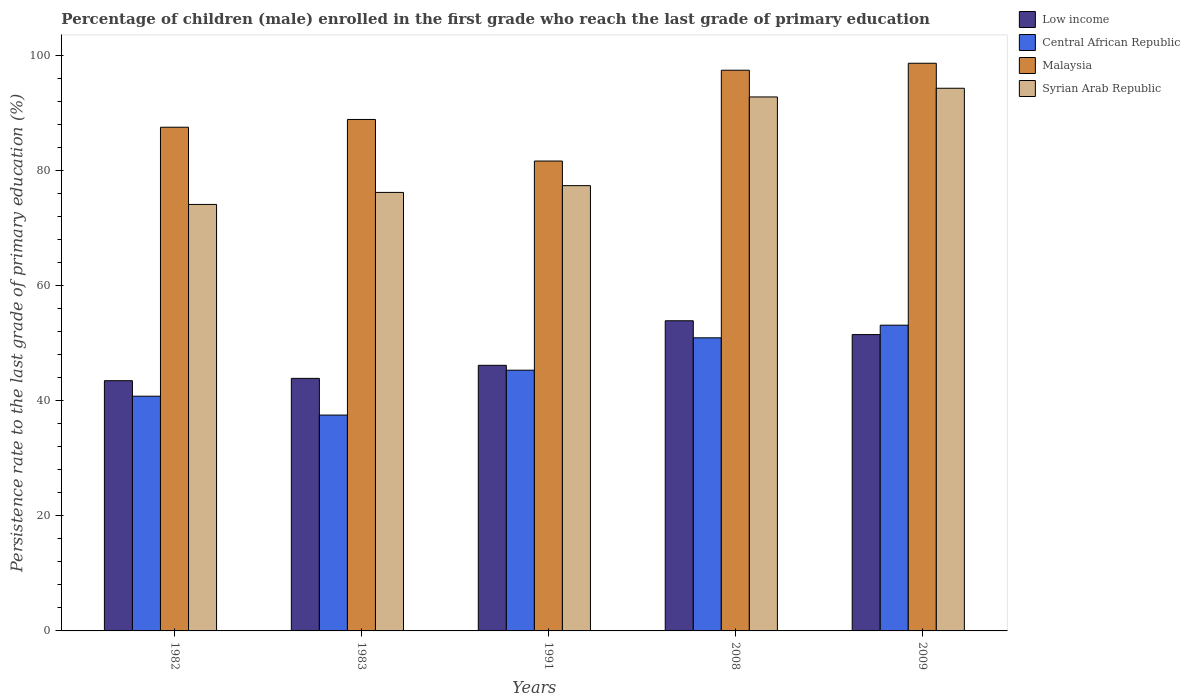How many groups of bars are there?
Keep it short and to the point. 5. How many bars are there on the 2nd tick from the right?
Your response must be concise. 4. In how many cases, is the number of bars for a given year not equal to the number of legend labels?
Offer a very short reply. 0. What is the persistence rate of children in Syrian Arab Republic in 1991?
Offer a very short reply. 77.38. Across all years, what is the maximum persistence rate of children in Central African Republic?
Your response must be concise. 53.13. Across all years, what is the minimum persistence rate of children in Syrian Arab Republic?
Make the answer very short. 74.12. What is the total persistence rate of children in Low income in the graph?
Your answer should be compact. 238.94. What is the difference between the persistence rate of children in Syrian Arab Republic in 1991 and that in 2008?
Your response must be concise. -15.42. What is the difference between the persistence rate of children in Malaysia in 2009 and the persistence rate of children in Central African Republic in 1991?
Offer a terse response. 53.34. What is the average persistence rate of children in Syrian Arab Republic per year?
Your answer should be compact. 82.96. In the year 1983, what is the difference between the persistence rate of children in Central African Republic and persistence rate of children in Malaysia?
Provide a short and direct response. -51.37. What is the ratio of the persistence rate of children in Malaysia in 1982 to that in 2009?
Make the answer very short. 0.89. Is the difference between the persistence rate of children in Central African Republic in 1991 and 2008 greater than the difference between the persistence rate of children in Malaysia in 1991 and 2008?
Offer a terse response. Yes. What is the difference between the highest and the second highest persistence rate of children in Central African Republic?
Provide a short and direct response. 2.2. What is the difference between the highest and the lowest persistence rate of children in Low income?
Keep it short and to the point. 10.42. In how many years, is the persistence rate of children in Malaysia greater than the average persistence rate of children in Malaysia taken over all years?
Offer a terse response. 2. Is the sum of the persistence rate of children in Malaysia in 2008 and 2009 greater than the maximum persistence rate of children in Central African Republic across all years?
Keep it short and to the point. Yes. What does the 4th bar from the left in 1982 represents?
Offer a terse response. Syrian Arab Republic. Are all the bars in the graph horizontal?
Give a very brief answer. No. How many years are there in the graph?
Give a very brief answer. 5. What is the difference between two consecutive major ticks on the Y-axis?
Ensure brevity in your answer.  20. Are the values on the major ticks of Y-axis written in scientific E-notation?
Provide a succinct answer. No. Does the graph contain grids?
Offer a terse response. No. Where does the legend appear in the graph?
Ensure brevity in your answer.  Top right. What is the title of the graph?
Offer a very short reply. Percentage of children (male) enrolled in the first grade who reach the last grade of primary education. What is the label or title of the X-axis?
Provide a succinct answer. Years. What is the label or title of the Y-axis?
Make the answer very short. Persistence rate to the last grade of primary education (%). What is the Persistence rate to the last grade of primary education (%) of Low income in 1982?
Your answer should be very brief. 43.49. What is the Persistence rate to the last grade of primary education (%) of Central African Republic in 1982?
Keep it short and to the point. 40.79. What is the Persistence rate to the last grade of primary education (%) of Malaysia in 1982?
Offer a very short reply. 87.54. What is the Persistence rate to the last grade of primary education (%) of Syrian Arab Republic in 1982?
Your response must be concise. 74.12. What is the Persistence rate to the last grade of primary education (%) of Low income in 1983?
Offer a terse response. 43.89. What is the Persistence rate to the last grade of primary education (%) of Central African Republic in 1983?
Your answer should be compact. 37.51. What is the Persistence rate to the last grade of primary education (%) in Malaysia in 1983?
Offer a terse response. 88.88. What is the Persistence rate to the last grade of primary education (%) of Syrian Arab Republic in 1983?
Offer a very short reply. 76.21. What is the Persistence rate to the last grade of primary education (%) in Low income in 1991?
Provide a succinct answer. 46.16. What is the Persistence rate to the last grade of primary education (%) in Central African Republic in 1991?
Give a very brief answer. 45.31. What is the Persistence rate to the last grade of primary education (%) of Malaysia in 1991?
Offer a terse response. 81.66. What is the Persistence rate to the last grade of primary education (%) of Syrian Arab Republic in 1991?
Make the answer very short. 77.38. What is the Persistence rate to the last grade of primary education (%) of Low income in 2008?
Offer a terse response. 53.9. What is the Persistence rate to the last grade of primary education (%) of Central African Republic in 2008?
Your response must be concise. 50.94. What is the Persistence rate to the last grade of primary education (%) of Malaysia in 2008?
Provide a short and direct response. 97.44. What is the Persistence rate to the last grade of primary education (%) in Syrian Arab Republic in 2008?
Ensure brevity in your answer.  92.8. What is the Persistence rate to the last grade of primary education (%) in Low income in 2009?
Offer a terse response. 51.5. What is the Persistence rate to the last grade of primary education (%) of Central African Republic in 2009?
Keep it short and to the point. 53.13. What is the Persistence rate to the last grade of primary education (%) of Malaysia in 2009?
Offer a terse response. 98.65. What is the Persistence rate to the last grade of primary education (%) of Syrian Arab Republic in 2009?
Your answer should be compact. 94.31. Across all years, what is the maximum Persistence rate to the last grade of primary education (%) of Low income?
Provide a short and direct response. 53.9. Across all years, what is the maximum Persistence rate to the last grade of primary education (%) of Central African Republic?
Offer a terse response. 53.13. Across all years, what is the maximum Persistence rate to the last grade of primary education (%) in Malaysia?
Give a very brief answer. 98.65. Across all years, what is the maximum Persistence rate to the last grade of primary education (%) in Syrian Arab Republic?
Offer a very short reply. 94.31. Across all years, what is the minimum Persistence rate to the last grade of primary education (%) of Low income?
Your answer should be very brief. 43.49. Across all years, what is the minimum Persistence rate to the last grade of primary education (%) in Central African Republic?
Your response must be concise. 37.51. Across all years, what is the minimum Persistence rate to the last grade of primary education (%) of Malaysia?
Keep it short and to the point. 81.66. Across all years, what is the minimum Persistence rate to the last grade of primary education (%) in Syrian Arab Republic?
Your response must be concise. 74.12. What is the total Persistence rate to the last grade of primary education (%) in Low income in the graph?
Ensure brevity in your answer.  238.94. What is the total Persistence rate to the last grade of primary education (%) of Central African Republic in the graph?
Give a very brief answer. 227.69. What is the total Persistence rate to the last grade of primary education (%) in Malaysia in the graph?
Your answer should be compact. 454.17. What is the total Persistence rate to the last grade of primary education (%) in Syrian Arab Republic in the graph?
Offer a very short reply. 414.82. What is the difference between the Persistence rate to the last grade of primary education (%) in Low income in 1982 and that in 1983?
Make the answer very short. -0.41. What is the difference between the Persistence rate to the last grade of primary education (%) in Central African Republic in 1982 and that in 1983?
Ensure brevity in your answer.  3.28. What is the difference between the Persistence rate to the last grade of primary education (%) of Malaysia in 1982 and that in 1983?
Give a very brief answer. -1.35. What is the difference between the Persistence rate to the last grade of primary education (%) of Syrian Arab Republic in 1982 and that in 1983?
Provide a short and direct response. -2.09. What is the difference between the Persistence rate to the last grade of primary education (%) in Low income in 1982 and that in 1991?
Offer a very short reply. -2.67. What is the difference between the Persistence rate to the last grade of primary education (%) in Central African Republic in 1982 and that in 1991?
Ensure brevity in your answer.  -4.52. What is the difference between the Persistence rate to the last grade of primary education (%) in Malaysia in 1982 and that in 1991?
Make the answer very short. 5.88. What is the difference between the Persistence rate to the last grade of primary education (%) in Syrian Arab Republic in 1982 and that in 1991?
Give a very brief answer. -3.26. What is the difference between the Persistence rate to the last grade of primary education (%) in Low income in 1982 and that in 2008?
Provide a succinct answer. -10.42. What is the difference between the Persistence rate to the last grade of primary education (%) of Central African Republic in 1982 and that in 2008?
Provide a succinct answer. -10.14. What is the difference between the Persistence rate to the last grade of primary education (%) in Malaysia in 1982 and that in 2008?
Ensure brevity in your answer.  -9.91. What is the difference between the Persistence rate to the last grade of primary education (%) of Syrian Arab Republic in 1982 and that in 2008?
Make the answer very short. -18.68. What is the difference between the Persistence rate to the last grade of primary education (%) of Low income in 1982 and that in 2009?
Provide a short and direct response. -8.02. What is the difference between the Persistence rate to the last grade of primary education (%) in Central African Republic in 1982 and that in 2009?
Make the answer very short. -12.34. What is the difference between the Persistence rate to the last grade of primary education (%) in Malaysia in 1982 and that in 2009?
Keep it short and to the point. -11.12. What is the difference between the Persistence rate to the last grade of primary education (%) in Syrian Arab Republic in 1982 and that in 2009?
Provide a short and direct response. -20.19. What is the difference between the Persistence rate to the last grade of primary education (%) of Low income in 1983 and that in 1991?
Offer a very short reply. -2.27. What is the difference between the Persistence rate to the last grade of primary education (%) of Central African Republic in 1983 and that in 1991?
Make the answer very short. -7.8. What is the difference between the Persistence rate to the last grade of primary education (%) in Malaysia in 1983 and that in 1991?
Keep it short and to the point. 7.23. What is the difference between the Persistence rate to the last grade of primary education (%) of Syrian Arab Republic in 1983 and that in 1991?
Your response must be concise. -1.18. What is the difference between the Persistence rate to the last grade of primary education (%) of Low income in 1983 and that in 2008?
Offer a terse response. -10.01. What is the difference between the Persistence rate to the last grade of primary education (%) in Central African Republic in 1983 and that in 2008?
Give a very brief answer. -13.43. What is the difference between the Persistence rate to the last grade of primary education (%) in Malaysia in 1983 and that in 2008?
Make the answer very short. -8.56. What is the difference between the Persistence rate to the last grade of primary education (%) in Syrian Arab Republic in 1983 and that in 2008?
Give a very brief answer. -16.59. What is the difference between the Persistence rate to the last grade of primary education (%) of Low income in 1983 and that in 2009?
Provide a succinct answer. -7.61. What is the difference between the Persistence rate to the last grade of primary education (%) of Central African Republic in 1983 and that in 2009?
Provide a short and direct response. -15.62. What is the difference between the Persistence rate to the last grade of primary education (%) in Malaysia in 1983 and that in 2009?
Your answer should be compact. -9.77. What is the difference between the Persistence rate to the last grade of primary education (%) in Syrian Arab Republic in 1983 and that in 2009?
Ensure brevity in your answer.  -18.1. What is the difference between the Persistence rate to the last grade of primary education (%) of Low income in 1991 and that in 2008?
Your answer should be compact. -7.74. What is the difference between the Persistence rate to the last grade of primary education (%) in Central African Republic in 1991 and that in 2008?
Make the answer very short. -5.63. What is the difference between the Persistence rate to the last grade of primary education (%) of Malaysia in 1991 and that in 2008?
Provide a succinct answer. -15.78. What is the difference between the Persistence rate to the last grade of primary education (%) in Syrian Arab Republic in 1991 and that in 2008?
Your answer should be very brief. -15.42. What is the difference between the Persistence rate to the last grade of primary education (%) of Low income in 1991 and that in 2009?
Offer a very short reply. -5.34. What is the difference between the Persistence rate to the last grade of primary education (%) in Central African Republic in 1991 and that in 2009?
Provide a short and direct response. -7.82. What is the difference between the Persistence rate to the last grade of primary education (%) in Malaysia in 1991 and that in 2009?
Your answer should be very brief. -16.99. What is the difference between the Persistence rate to the last grade of primary education (%) of Syrian Arab Republic in 1991 and that in 2009?
Offer a very short reply. -16.92. What is the difference between the Persistence rate to the last grade of primary education (%) in Central African Republic in 2008 and that in 2009?
Provide a succinct answer. -2.2. What is the difference between the Persistence rate to the last grade of primary education (%) in Malaysia in 2008 and that in 2009?
Make the answer very short. -1.21. What is the difference between the Persistence rate to the last grade of primary education (%) of Syrian Arab Republic in 2008 and that in 2009?
Keep it short and to the point. -1.51. What is the difference between the Persistence rate to the last grade of primary education (%) of Low income in 1982 and the Persistence rate to the last grade of primary education (%) of Central African Republic in 1983?
Give a very brief answer. 5.98. What is the difference between the Persistence rate to the last grade of primary education (%) of Low income in 1982 and the Persistence rate to the last grade of primary education (%) of Malaysia in 1983?
Make the answer very short. -45.4. What is the difference between the Persistence rate to the last grade of primary education (%) of Low income in 1982 and the Persistence rate to the last grade of primary education (%) of Syrian Arab Republic in 1983?
Your answer should be very brief. -32.72. What is the difference between the Persistence rate to the last grade of primary education (%) in Central African Republic in 1982 and the Persistence rate to the last grade of primary education (%) in Malaysia in 1983?
Offer a very short reply. -48.09. What is the difference between the Persistence rate to the last grade of primary education (%) in Central African Republic in 1982 and the Persistence rate to the last grade of primary education (%) in Syrian Arab Republic in 1983?
Offer a very short reply. -35.41. What is the difference between the Persistence rate to the last grade of primary education (%) of Malaysia in 1982 and the Persistence rate to the last grade of primary education (%) of Syrian Arab Republic in 1983?
Your answer should be very brief. 11.33. What is the difference between the Persistence rate to the last grade of primary education (%) of Low income in 1982 and the Persistence rate to the last grade of primary education (%) of Central African Republic in 1991?
Offer a terse response. -1.83. What is the difference between the Persistence rate to the last grade of primary education (%) of Low income in 1982 and the Persistence rate to the last grade of primary education (%) of Malaysia in 1991?
Ensure brevity in your answer.  -38.17. What is the difference between the Persistence rate to the last grade of primary education (%) of Low income in 1982 and the Persistence rate to the last grade of primary education (%) of Syrian Arab Republic in 1991?
Make the answer very short. -33.9. What is the difference between the Persistence rate to the last grade of primary education (%) of Central African Republic in 1982 and the Persistence rate to the last grade of primary education (%) of Malaysia in 1991?
Provide a short and direct response. -40.87. What is the difference between the Persistence rate to the last grade of primary education (%) of Central African Republic in 1982 and the Persistence rate to the last grade of primary education (%) of Syrian Arab Republic in 1991?
Offer a terse response. -36.59. What is the difference between the Persistence rate to the last grade of primary education (%) in Malaysia in 1982 and the Persistence rate to the last grade of primary education (%) in Syrian Arab Republic in 1991?
Provide a succinct answer. 10.15. What is the difference between the Persistence rate to the last grade of primary education (%) of Low income in 1982 and the Persistence rate to the last grade of primary education (%) of Central African Republic in 2008?
Offer a very short reply. -7.45. What is the difference between the Persistence rate to the last grade of primary education (%) in Low income in 1982 and the Persistence rate to the last grade of primary education (%) in Malaysia in 2008?
Your answer should be very brief. -53.96. What is the difference between the Persistence rate to the last grade of primary education (%) in Low income in 1982 and the Persistence rate to the last grade of primary education (%) in Syrian Arab Republic in 2008?
Provide a succinct answer. -49.31. What is the difference between the Persistence rate to the last grade of primary education (%) in Central African Republic in 1982 and the Persistence rate to the last grade of primary education (%) in Malaysia in 2008?
Keep it short and to the point. -56.65. What is the difference between the Persistence rate to the last grade of primary education (%) of Central African Republic in 1982 and the Persistence rate to the last grade of primary education (%) of Syrian Arab Republic in 2008?
Make the answer very short. -52.01. What is the difference between the Persistence rate to the last grade of primary education (%) of Malaysia in 1982 and the Persistence rate to the last grade of primary education (%) of Syrian Arab Republic in 2008?
Provide a short and direct response. -5.26. What is the difference between the Persistence rate to the last grade of primary education (%) in Low income in 1982 and the Persistence rate to the last grade of primary education (%) in Central African Republic in 2009?
Your answer should be compact. -9.65. What is the difference between the Persistence rate to the last grade of primary education (%) in Low income in 1982 and the Persistence rate to the last grade of primary education (%) in Malaysia in 2009?
Your response must be concise. -55.17. What is the difference between the Persistence rate to the last grade of primary education (%) of Low income in 1982 and the Persistence rate to the last grade of primary education (%) of Syrian Arab Republic in 2009?
Give a very brief answer. -50.82. What is the difference between the Persistence rate to the last grade of primary education (%) in Central African Republic in 1982 and the Persistence rate to the last grade of primary education (%) in Malaysia in 2009?
Your answer should be compact. -57.86. What is the difference between the Persistence rate to the last grade of primary education (%) of Central African Republic in 1982 and the Persistence rate to the last grade of primary education (%) of Syrian Arab Republic in 2009?
Give a very brief answer. -53.52. What is the difference between the Persistence rate to the last grade of primary education (%) of Malaysia in 1982 and the Persistence rate to the last grade of primary education (%) of Syrian Arab Republic in 2009?
Keep it short and to the point. -6.77. What is the difference between the Persistence rate to the last grade of primary education (%) in Low income in 1983 and the Persistence rate to the last grade of primary education (%) in Central African Republic in 1991?
Your response must be concise. -1.42. What is the difference between the Persistence rate to the last grade of primary education (%) in Low income in 1983 and the Persistence rate to the last grade of primary education (%) in Malaysia in 1991?
Ensure brevity in your answer.  -37.77. What is the difference between the Persistence rate to the last grade of primary education (%) in Low income in 1983 and the Persistence rate to the last grade of primary education (%) in Syrian Arab Republic in 1991?
Provide a short and direct response. -33.49. What is the difference between the Persistence rate to the last grade of primary education (%) of Central African Republic in 1983 and the Persistence rate to the last grade of primary education (%) of Malaysia in 1991?
Provide a short and direct response. -44.15. What is the difference between the Persistence rate to the last grade of primary education (%) of Central African Republic in 1983 and the Persistence rate to the last grade of primary education (%) of Syrian Arab Republic in 1991?
Your answer should be compact. -39.87. What is the difference between the Persistence rate to the last grade of primary education (%) of Malaysia in 1983 and the Persistence rate to the last grade of primary education (%) of Syrian Arab Republic in 1991?
Make the answer very short. 11.5. What is the difference between the Persistence rate to the last grade of primary education (%) in Low income in 1983 and the Persistence rate to the last grade of primary education (%) in Central African Republic in 2008?
Offer a very short reply. -7.05. What is the difference between the Persistence rate to the last grade of primary education (%) in Low income in 1983 and the Persistence rate to the last grade of primary education (%) in Malaysia in 2008?
Your response must be concise. -53.55. What is the difference between the Persistence rate to the last grade of primary education (%) in Low income in 1983 and the Persistence rate to the last grade of primary education (%) in Syrian Arab Republic in 2008?
Ensure brevity in your answer.  -48.91. What is the difference between the Persistence rate to the last grade of primary education (%) in Central African Republic in 1983 and the Persistence rate to the last grade of primary education (%) in Malaysia in 2008?
Provide a succinct answer. -59.93. What is the difference between the Persistence rate to the last grade of primary education (%) of Central African Republic in 1983 and the Persistence rate to the last grade of primary education (%) of Syrian Arab Republic in 2008?
Ensure brevity in your answer.  -55.29. What is the difference between the Persistence rate to the last grade of primary education (%) in Malaysia in 1983 and the Persistence rate to the last grade of primary education (%) in Syrian Arab Republic in 2008?
Offer a terse response. -3.92. What is the difference between the Persistence rate to the last grade of primary education (%) in Low income in 1983 and the Persistence rate to the last grade of primary education (%) in Central African Republic in 2009?
Provide a short and direct response. -9.24. What is the difference between the Persistence rate to the last grade of primary education (%) in Low income in 1983 and the Persistence rate to the last grade of primary education (%) in Malaysia in 2009?
Keep it short and to the point. -54.76. What is the difference between the Persistence rate to the last grade of primary education (%) in Low income in 1983 and the Persistence rate to the last grade of primary education (%) in Syrian Arab Republic in 2009?
Your response must be concise. -50.42. What is the difference between the Persistence rate to the last grade of primary education (%) in Central African Republic in 1983 and the Persistence rate to the last grade of primary education (%) in Malaysia in 2009?
Your answer should be compact. -61.14. What is the difference between the Persistence rate to the last grade of primary education (%) in Central African Republic in 1983 and the Persistence rate to the last grade of primary education (%) in Syrian Arab Republic in 2009?
Ensure brevity in your answer.  -56.8. What is the difference between the Persistence rate to the last grade of primary education (%) of Malaysia in 1983 and the Persistence rate to the last grade of primary education (%) of Syrian Arab Republic in 2009?
Your answer should be compact. -5.42. What is the difference between the Persistence rate to the last grade of primary education (%) in Low income in 1991 and the Persistence rate to the last grade of primary education (%) in Central African Republic in 2008?
Give a very brief answer. -4.78. What is the difference between the Persistence rate to the last grade of primary education (%) of Low income in 1991 and the Persistence rate to the last grade of primary education (%) of Malaysia in 2008?
Keep it short and to the point. -51.28. What is the difference between the Persistence rate to the last grade of primary education (%) of Low income in 1991 and the Persistence rate to the last grade of primary education (%) of Syrian Arab Republic in 2008?
Ensure brevity in your answer.  -46.64. What is the difference between the Persistence rate to the last grade of primary education (%) of Central African Republic in 1991 and the Persistence rate to the last grade of primary education (%) of Malaysia in 2008?
Your answer should be very brief. -52.13. What is the difference between the Persistence rate to the last grade of primary education (%) of Central African Republic in 1991 and the Persistence rate to the last grade of primary education (%) of Syrian Arab Republic in 2008?
Your answer should be very brief. -47.49. What is the difference between the Persistence rate to the last grade of primary education (%) in Malaysia in 1991 and the Persistence rate to the last grade of primary education (%) in Syrian Arab Republic in 2008?
Your answer should be very brief. -11.14. What is the difference between the Persistence rate to the last grade of primary education (%) in Low income in 1991 and the Persistence rate to the last grade of primary education (%) in Central African Republic in 2009?
Ensure brevity in your answer.  -6.98. What is the difference between the Persistence rate to the last grade of primary education (%) of Low income in 1991 and the Persistence rate to the last grade of primary education (%) of Malaysia in 2009?
Ensure brevity in your answer.  -52.49. What is the difference between the Persistence rate to the last grade of primary education (%) of Low income in 1991 and the Persistence rate to the last grade of primary education (%) of Syrian Arab Republic in 2009?
Provide a short and direct response. -48.15. What is the difference between the Persistence rate to the last grade of primary education (%) in Central African Republic in 1991 and the Persistence rate to the last grade of primary education (%) in Malaysia in 2009?
Make the answer very short. -53.34. What is the difference between the Persistence rate to the last grade of primary education (%) in Central African Republic in 1991 and the Persistence rate to the last grade of primary education (%) in Syrian Arab Republic in 2009?
Your answer should be very brief. -49. What is the difference between the Persistence rate to the last grade of primary education (%) in Malaysia in 1991 and the Persistence rate to the last grade of primary education (%) in Syrian Arab Republic in 2009?
Provide a succinct answer. -12.65. What is the difference between the Persistence rate to the last grade of primary education (%) in Low income in 2008 and the Persistence rate to the last grade of primary education (%) in Central African Republic in 2009?
Your answer should be very brief. 0.77. What is the difference between the Persistence rate to the last grade of primary education (%) of Low income in 2008 and the Persistence rate to the last grade of primary education (%) of Malaysia in 2009?
Make the answer very short. -44.75. What is the difference between the Persistence rate to the last grade of primary education (%) of Low income in 2008 and the Persistence rate to the last grade of primary education (%) of Syrian Arab Republic in 2009?
Your response must be concise. -40.41. What is the difference between the Persistence rate to the last grade of primary education (%) in Central African Republic in 2008 and the Persistence rate to the last grade of primary education (%) in Malaysia in 2009?
Your response must be concise. -47.72. What is the difference between the Persistence rate to the last grade of primary education (%) in Central African Republic in 2008 and the Persistence rate to the last grade of primary education (%) in Syrian Arab Republic in 2009?
Ensure brevity in your answer.  -43.37. What is the difference between the Persistence rate to the last grade of primary education (%) in Malaysia in 2008 and the Persistence rate to the last grade of primary education (%) in Syrian Arab Republic in 2009?
Your answer should be very brief. 3.13. What is the average Persistence rate to the last grade of primary education (%) in Low income per year?
Provide a succinct answer. 47.79. What is the average Persistence rate to the last grade of primary education (%) of Central African Republic per year?
Offer a very short reply. 45.54. What is the average Persistence rate to the last grade of primary education (%) of Malaysia per year?
Offer a terse response. 90.83. What is the average Persistence rate to the last grade of primary education (%) in Syrian Arab Republic per year?
Your answer should be very brief. 82.96. In the year 1982, what is the difference between the Persistence rate to the last grade of primary education (%) of Low income and Persistence rate to the last grade of primary education (%) of Central African Republic?
Provide a succinct answer. 2.69. In the year 1982, what is the difference between the Persistence rate to the last grade of primary education (%) of Low income and Persistence rate to the last grade of primary education (%) of Malaysia?
Make the answer very short. -44.05. In the year 1982, what is the difference between the Persistence rate to the last grade of primary education (%) in Low income and Persistence rate to the last grade of primary education (%) in Syrian Arab Republic?
Your answer should be very brief. -30.63. In the year 1982, what is the difference between the Persistence rate to the last grade of primary education (%) in Central African Republic and Persistence rate to the last grade of primary education (%) in Malaysia?
Offer a terse response. -46.74. In the year 1982, what is the difference between the Persistence rate to the last grade of primary education (%) of Central African Republic and Persistence rate to the last grade of primary education (%) of Syrian Arab Republic?
Ensure brevity in your answer.  -33.33. In the year 1982, what is the difference between the Persistence rate to the last grade of primary education (%) of Malaysia and Persistence rate to the last grade of primary education (%) of Syrian Arab Republic?
Your answer should be very brief. 13.42. In the year 1983, what is the difference between the Persistence rate to the last grade of primary education (%) in Low income and Persistence rate to the last grade of primary education (%) in Central African Republic?
Offer a very short reply. 6.38. In the year 1983, what is the difference between the Persistence rate to the last grade of primary education (%) of Low income and Persistence rate to the last grade of primary education (%) of Malaysia?
Provide a short and direct response. -44.99. In the year 1983, what is the difference between the Persistence rate to the last grade of primary education (%) in Low income and Persistence rate to the last grade of primary education (%) in Syrian Arab Republic?
Keep it short and to the point. -32.31. In the year 1983, what is the difference between the Persistence rate to the last grade of primary education (%) in Central African Republic and Persistence rate to the last grade of primary education (%) in Malaysia?
Keep it short and to the point. -51.37. In the year 1983, what is the difference between the Persistence rate to the last grade of primary education (%) of Central African Republic and Persistence rate to the last grade of primary education (%) of Syrian Arab Republic?
Keep it short and to the point. -38.7. In the year 1983, what is the difference between the Persistence rate to the last grade of primary education (%) in Malaysia and Persistence rate to the last grade of primary education (%) in Syrian Arab Republic?
Give a very brief answer. 12.68. In the year 1991, what is the difference between the Persistence rate to the last grade of primary education (%) in Low income and Persistence rate to the last grade of primary education (%) in Central African Republic?
Offer a very short reply. 0.85. In the year 1991, what is the difference between the Persistence rate to the last grade of primary education (%) in Low income and Persistence rate to the last grade of primary education (%) in Malaysia?
Offer a very short reply. -35.5. In the year 1991, what is the difference between the Persistence rate to the last grade of primary education (%) in Low income and Persistence rate to the last grade of primary education (%) in Syrian Arab Republic?
Your response must be concise. -31.23. In the year 1991, what is the difference between the Persistence rate to the last grade of primary education (%) in Central African Republic and Persistence rate to the last grade of primary education (%) in Malaysia?
Provide a short and direct response. -36.35. In the year 1991, what is the difference between the Persistence rate to the last grade of primary education (%) in Central African Republic and Persistence rate to the last grade of primary education (%) in Syrian Arab Republic?
Provide a short and direct response. -32.07. In the year 1991, what is the difference between the Persistence rate to the last grade of primary education (%) in Malaysia and Persistence rate to the last grade of primary education (%) in Syrian Arab Republic?
Your answer should be very brief. 4.27. In the year 2008, what is the difference between the Persistence rate to the last grade of primary education (%) of Low income and Persistence rate to the last grade of primary education (%) of Central African Republic?
Make the answer very short. 2.96. In the year 2008, what is the difference between the Persistence rate to the last grade of primary education (%) in Low income and Persistence rate to the last grade of primary education (%) in Malaysia?
Offer a very short reply. -43.54. In the year 2008, what is the difference between the Persistence rate to the last grade of primary education (%) in Low income and Persistence rate to the last grade of primary education (%) in Syrian Arab Republic?
Your answer should be very brief. -38.9. In the year 2008, what is the difference between the Persistence rate to the last grade of primary education (%) of Central African Republic and Persistence rate to the last grade of primary education (%) of Malaysia?
Give a very brief answer. -46.51. In the year 2008, what is the difference between the Persistence rate to the last grade of primary education (%) in Central African Republic and Persistence rate to the last grade of primary education (%) in Syrian Arab Republic?
Your answer should be compact. -41.86. In the year 2008, what is the difference between the Persistence rate to the last grade of primary education (%) of Malaysia and Persistence rate to the last grade of primary education (%) of Syrian Arab Republic?
Your answer should be very brief. 4.64. In the year 2009, what is the difference between the Persistence rate to the last grade of primary education (%) of Low income and Persistence rate to the last grade of primary education (%) of Central African Republic?
Provide a short and direct response. -1.63. In the year 2009, what is the difference between the Persistence rate to the last grade of primary education (%) of Low income and Persistence rate to the last grade of primary education (%) of Malaysia?
Your answer should be compact. -47.15. In the year 2009, what is the difference between the Persistence rate to the last grade of primary education (%) in Low income and Persistence rate to the last grade of primary education (%) in Syrian Arab Republic?
Offer a very short reply. -42.81. In the year 2009, what is the difference between the Persistence rate to the last grade of primary education (%) of Central African Republic and Persistence rate to the last grade of primary education (%) of Malaysia?
Your answer should be very brief. -45.52. In the year 2009, what is the difference between the Persistence rate to the last grade of primary education (%) of Central African Republic and Persistence rate to the last grade of primary education (%) of Syrian Arab Republic?
Keep it short and to the point. -41.17. In the year 2009, what is the difference between the Persistence rate to the last grade of primary education (%) of Malaysia and Persistence rate to the last grade of primary education (%) of Syrian Arab Republic?
Offer a terse response. 4.34. What is the ratio of the Persistence rate to the last grade of primary education (%) of Low income in 1982 to that in 1983?
Offer a terse response. 0.99. What is the ratio of the Persistence rate to the last grade of primary education (%) in Central African Republic in 1982 to that in 1983?
Provide a short and direct response. 1.09. What is the ratio of the Persistence rate to the last grade of primary education (%) of Malaysia in 1982 to that in 1983?
Provide a short and direct response. 0.98. What is the ratio of the Persistence rate to the last grade of primary education (%) in Syrian Arab Republic in 1982 to that in 1983?
Provide a short and direct response. 0.97. What is the ratio of the Persistence rate to the last grade of primary education (%) in Low income in 1982 to that in 1991?
Ensure brevity in your answer.  0.94. What is the ratio of the Persistence rate to the last grade of primary education (%) of Central African Republic in 1982 to that in 1991?
Your response must be concise. 0.9. What is the ratio of the Persistence rate to the last grade of primary education (%) in Malaysia in 1982 to that in 1991?
Keep it short and to the point. 1.07. What is the ratio of the Persistence rate to the last grade of primary education (%) in Syrian Arab Republic in 1982 to that in 1991?
Make the answer very short. 0.96. What is the ratio of the Persistence rate to the last grade of primary education (%) in Low income in 1982 to that in 2008?
Your response must be concise. 0.81. What is the ratio of the Persistence rate to the last grade of primary education (%) in Central African Republic in 1982 to that in 2008?
Provide a succinct answer. 0.8. What is the ratio of the Persistence rate to the last grade of primary education (%) of Malaysia in 1982 to that in 2008?
Offer a terse response. 0.9. What is the ratio of the Persistence rate to the last grade of primary education (%) of Syrian Arab Republic in 1982 to that in 2008?
Provide a succinct answer. 0.8. What is the ratio of the Persistence rate to the last grade of primary education (%) of Low income in 1982 to that in 2009?
Provide a short and direct response. 0.84. What is the ratio of the Persistence rate to the last grade of primary education (%) of Central African Republic in 1982 to that in 2009?
Give a very brief answer. 0.77. What is the ratio of the Persistence rate to the last grade of primary education (%) of Malaysia in 1982 to that in 2009?
Provide a succinct answer. 0.89. What is the ratio of the Persistence rate to the last grade of primary education (%) of Syrian Arab Republic in 1982 to that in 2009?
Offer a very short reply. 0.79. What is the ratio of the Persistence rate to the last grade of primary education (%) in Low income in 1983 to that in 1991?
Give a very brief answer. 0.95. What is the ratio of the Persistence rate to the last grade of primary education (%) of Central African Republic in 1983 to that in 1991?
Give a very brief answer. 0.83. What is the ratio of the Persistence rate to the last grade of primary education (%) of Malaysia in 1983 to that in 1991?
Ensure brevity in your answer.  1.09. What is the ratio of the Persistence rate to the last grade of primary education (%) in Syrian Arab Republic in 1983 to that in 1991?
Your answer should be compact. 0.98. What is the ratio of the Persistence rate to the last grade of primary education (%) in Low income in 1983 to that in 2008?
Give a very brief answer. 0.81. What is the ratio of the Persistence rate to the last grade of primary education (%) of Central African Republic in 1983 to that in 2008?
Your response must be concise. 0.74. What is the ratio of the Persistence rate to the last grade of primary education (%) of Malaysia in 1983 to that in 2008?
Make the answer very short. 0.91. What is the ratio of the Persistence rate to the last grade of primary education (%) of Syrian Arab Republic in 1983 to that in 2008?
Ensure brevity in your answer.  0.82. What is the ratio of the Persistence rate to the last grade of primary education (%) of Low income in 1983 to that in 2009?
Ensure brevity in your answer.  0.85. What is the ratio of the Persistence rate to the last grade of primary education (%) of Central African Republic in 1983 to that in 2009?
Ensure brevity in your answer.  0.71. What is the ratio of the Persistence rate to the last grade of primary education (%) in Malaysia in 1983 to that in 2009?
Your answer should be compact. 0.9. What is the ratio of the Persistence rate to the last grade of primary education (%) of Syrian Arab Republic in 1983 to that in 2009?
Offer a terse response. 0.81. What is the ratio of the Persistence rate to the last grade of primary education (%) in Low income in 1991 to that in 2008?
Your answer should be very brief. 0.86. What is the ratio of the Persistence rate to the last grade of primary education (%) in Central African Republic in 1991 to that in 2008?
Your response must be concise. 0.89. What is the ratio of the Persistence rate to the last grade of primary education (%) in Malaysia in 1991 to that in 2008?
Offer a terse response. 0.84. What is the ratio of the Persistence rate to the last grade of primary education (%) in Syrian Arab Republic in 1991 to that in 2008?
Offer a terse response. 0.83. What is the ratio of the Persistence rate to the last grade of primary education (%) of Low income in 1991 to that in 2009?
Keep it short and to the point. 0.9. What is the ratio of the Persistence rate to the last grade of primary education (%) of Central African Republic in 1991 to that in 2009?
Provide a succinct answer. 0.85. What is the ratio of the Persistence rate to the last grade of primary education (%) in Malaysia in 1991 to that in 2009?
Offer a terse response. 0.83. What is the ratio of the Persistence rate to the last grade of primary education (%) in Syrian Arab Republic in 1991 to that in 2009?
Provide a short and direct response. 0.82. What is the ratio of the Persistence rate to the last grade of primary education (%) in Low income in 2008 to that in 2009?
Ensure brevity in your answer.  1.05. What is the ratio of the Persistence rate to the last grade of primary education (%) in Central African Republic in 2008 to that in 2009?
Your answer should be very brief. 0.96. What is the ratio of the Persistence rate to the last grade of primary education (%) in Malaysia in 2008 to that in 2009?
Keep it short and to the point. 0.99. What is the difference between the highest and the second highest Persistence rate to the last grade of primary education (%) of Central African Republic?
Make the answer very short. 2.2. What is the difference between the highest and the second highest Persistence rate to the last grade of primary education (%) of Malaysia?
Ensure brevity in your answer.  1.21. What is the difference between the highest and the second highest Persistence rate to the last grade of primary education (%) in Syrian Arab Republic?
Ensure brevity in your answer.  1.51. What is the difference between the highest and the lowest Persistence rate to the last grade of primary education (%) of Low income?
Your answer should be compact. 10.42. What is the difference between the highest and the lowest Persistence rate to the last grade of primary education (%) of Central African Republic?
Offer a terse response. 15.62. What is the difference between the highest and the lowest Persistence rate to the last grade of primary education (%) in Malaysia?
Your answer should be very brief. 16.99. What is the difference between the highest and the lowest Persistence rate to the last grade of primary education (%) in Syrian Arab Republic?
Ensure brevity in your answer.  20.19. 